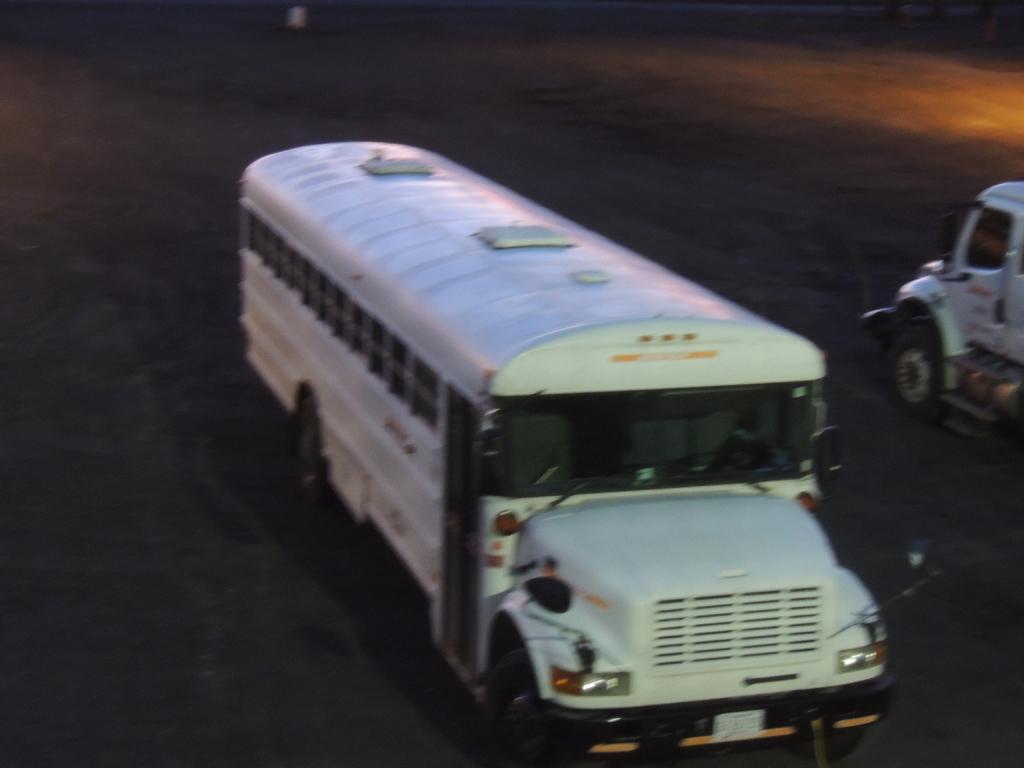Can you describe this image briefly? In this image I see the road on which there are 2 vehicles which are of white in color. 